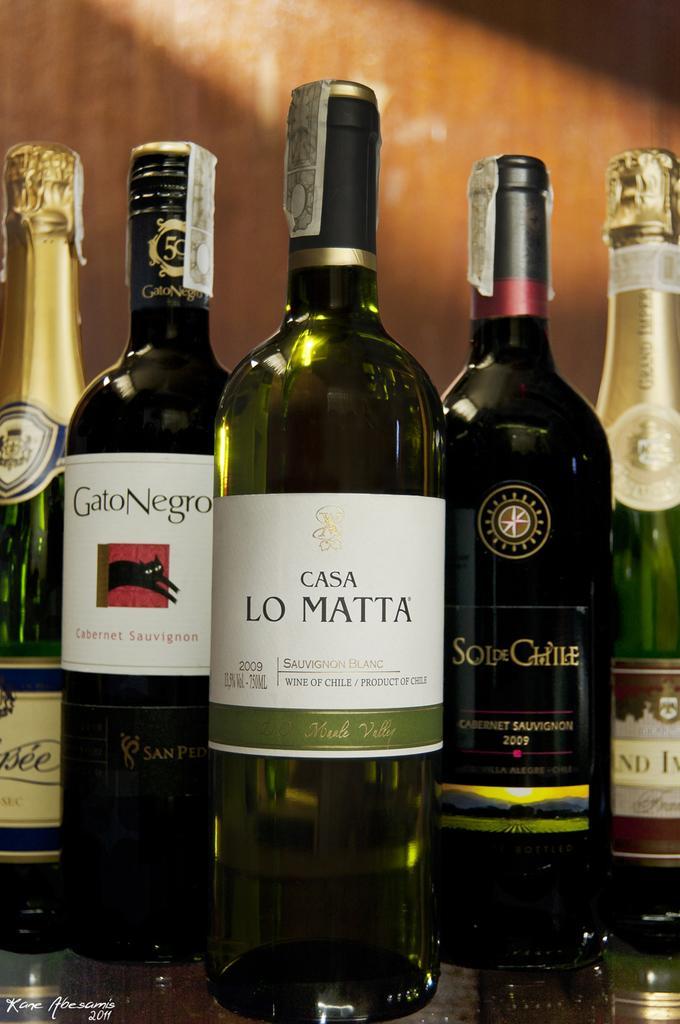Please provide a concise description of this image. There are five wine bottles placed on the table. In the background there is a wooden wall. 